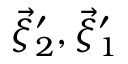<formula> <loc_0><loc_0><loc_500><loc_500>\vec { \xi } _ { 2 } ^ { \prime } , \vec { \xi } _ { 1 } ^ { \prime }</formula> 